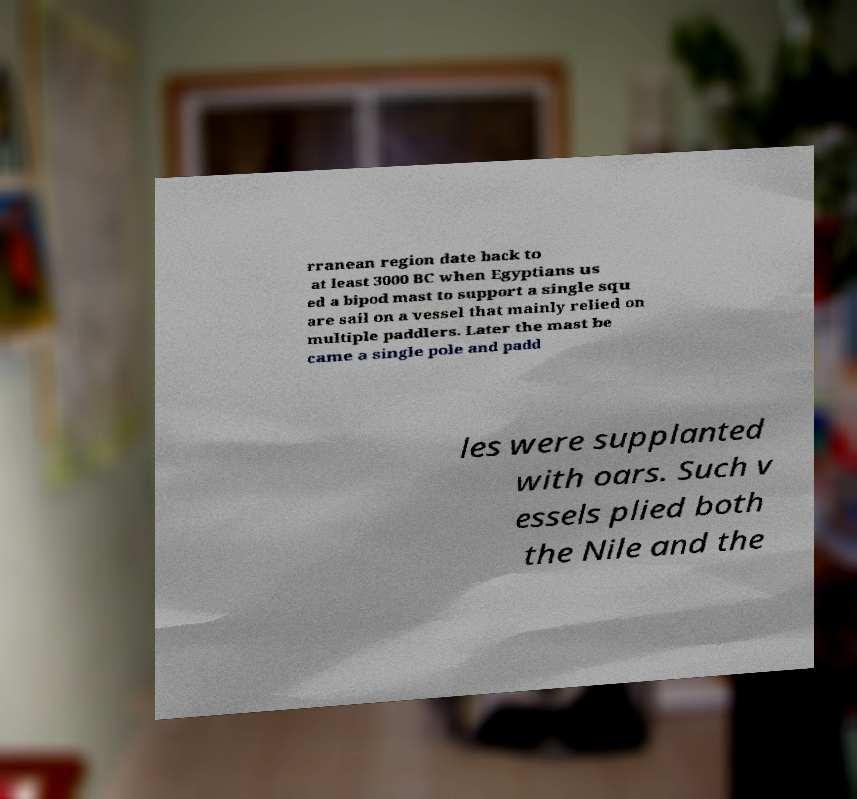There's text embedded in this image that I need extracted. Can you transcribe it verbatim? rranean region date back to at least 3000 BC when Egyptians us ed a bipod mast to support a single squ are sail on a vessel that mainly relied on multiple paddlers. Later the mast be came a single pole and padd les were supplanted with oars. Such v essels plied both the Nile and the 